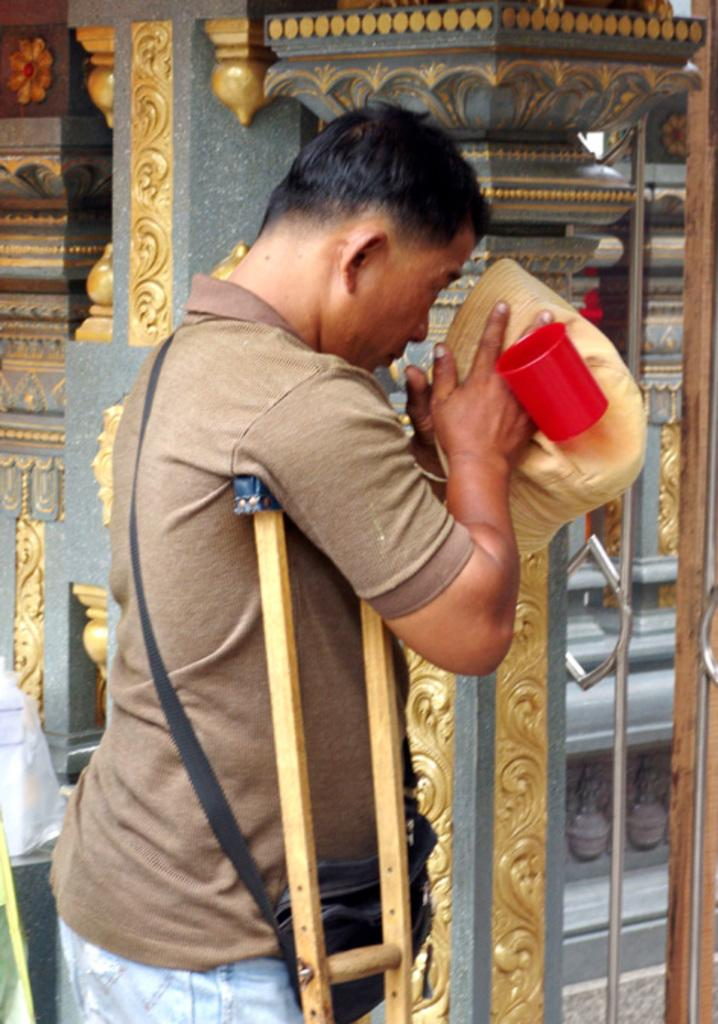What is the main subject of the image? There is a person in the image. What is the person doing in the image? The person is standing. What object is the person holding in the image? The person is holding a mug in his hand. What invention is the person demonstrating in the image? There is no invention being demonstrated in the image; the person is simply standing and holding a mug. What type of business is the person representing in the image? There is no indication of a business in the image; it only shows a person standing and holding a mug. 